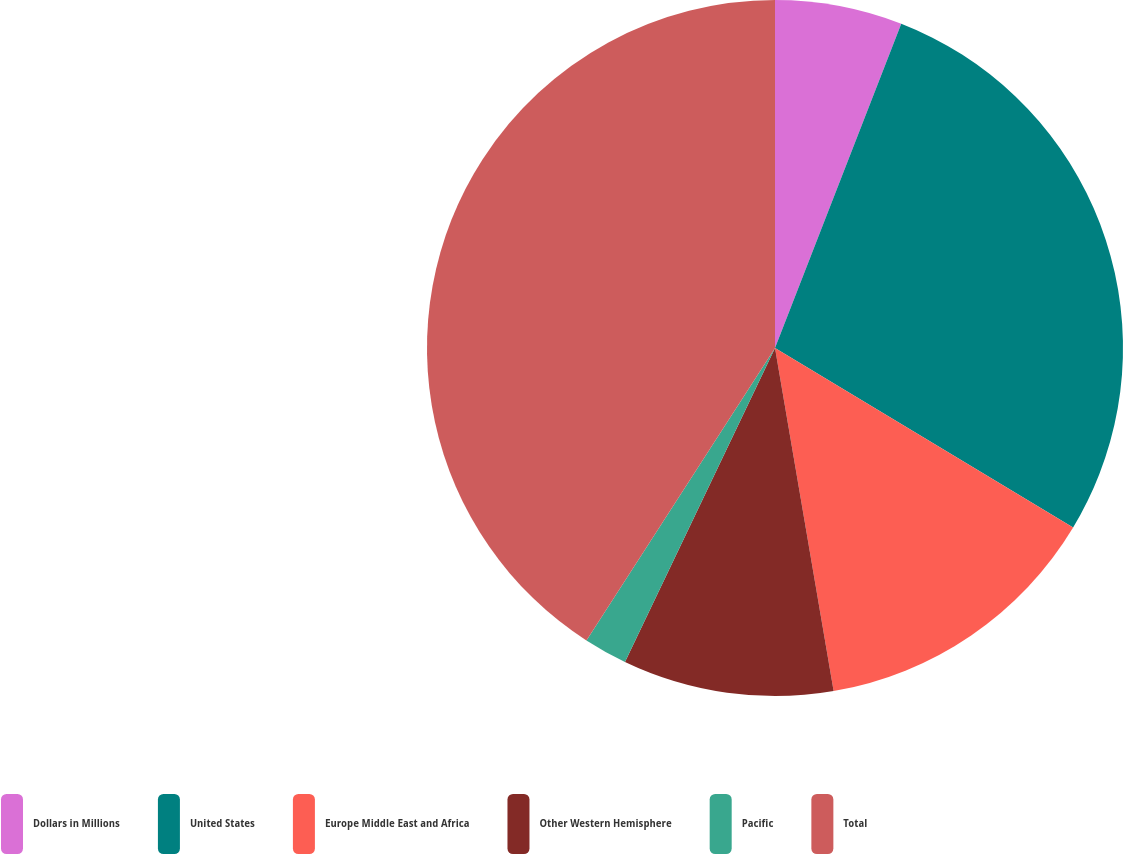Convert chart to OTSL. <chart><loc_0><loc_0><loc_500><loc_500><pie_chart><fcel>Dollars in Millions<fcel>United States<fcel>Europe Middle East and Africa<fcel>Other Western Hemisphere<fcel>Pacific<fcel>Total<nl><fcel>5.91%<fcel>27.72%<fcel>13.68%<fcel>9.79%<fcel>2.02%<fcel>40.89%<nl></chart> 